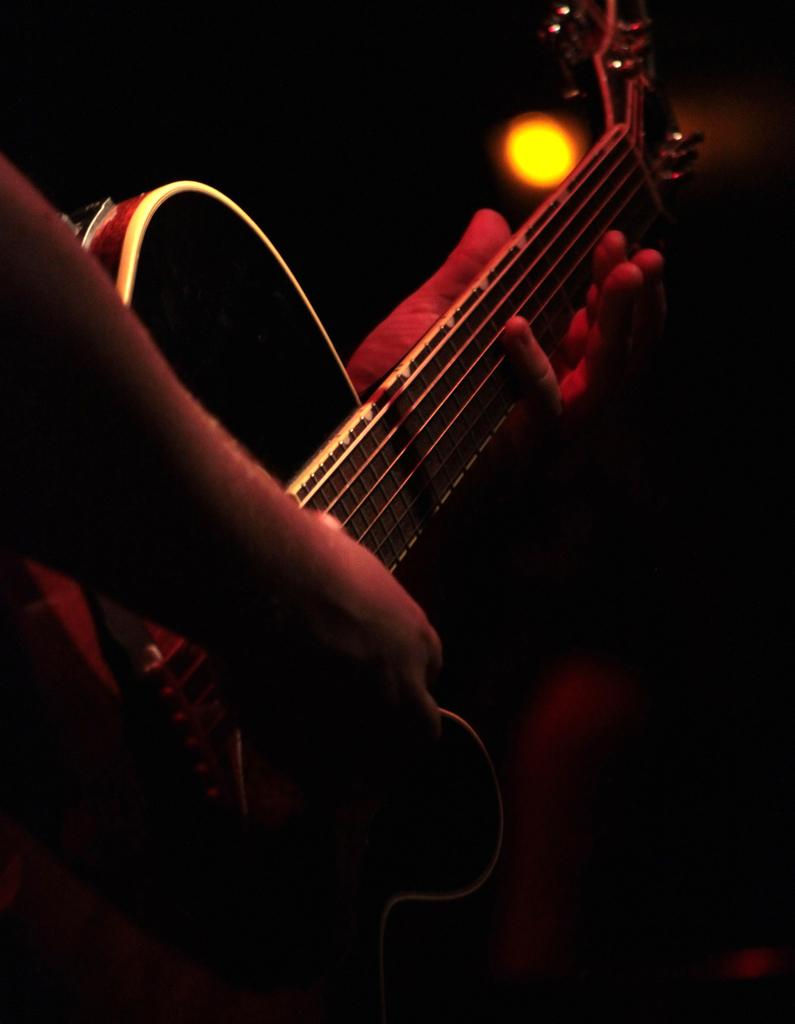Who or what is the main subject in the image? There is a person in the image. What is the person holding in his hand? The person is holding a guitar in his hand. Can you see any jellyfish in the image? No, there are no jellyfish present in the image. 